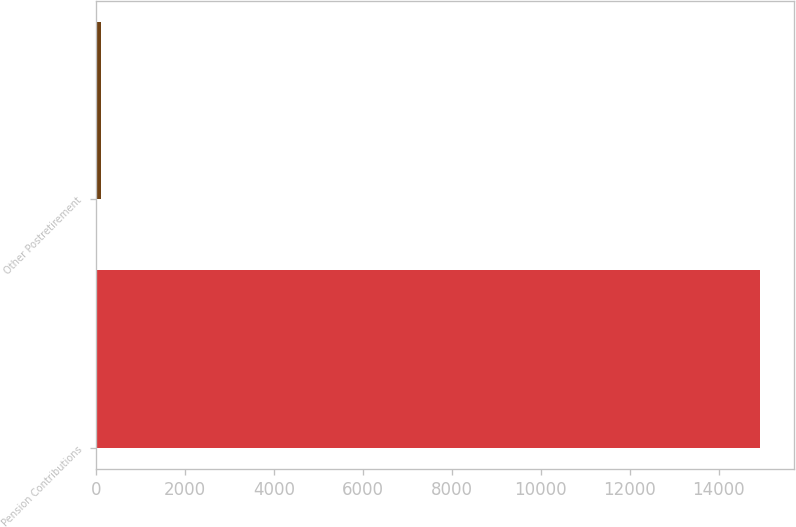<chart> <loc_0><loc_0><loc_500><loc_500><bar_chart><fcel>Pension Contributions<fcel>Other Postretirement<nl><fcel>14933<fcel>110<nl></chart> 